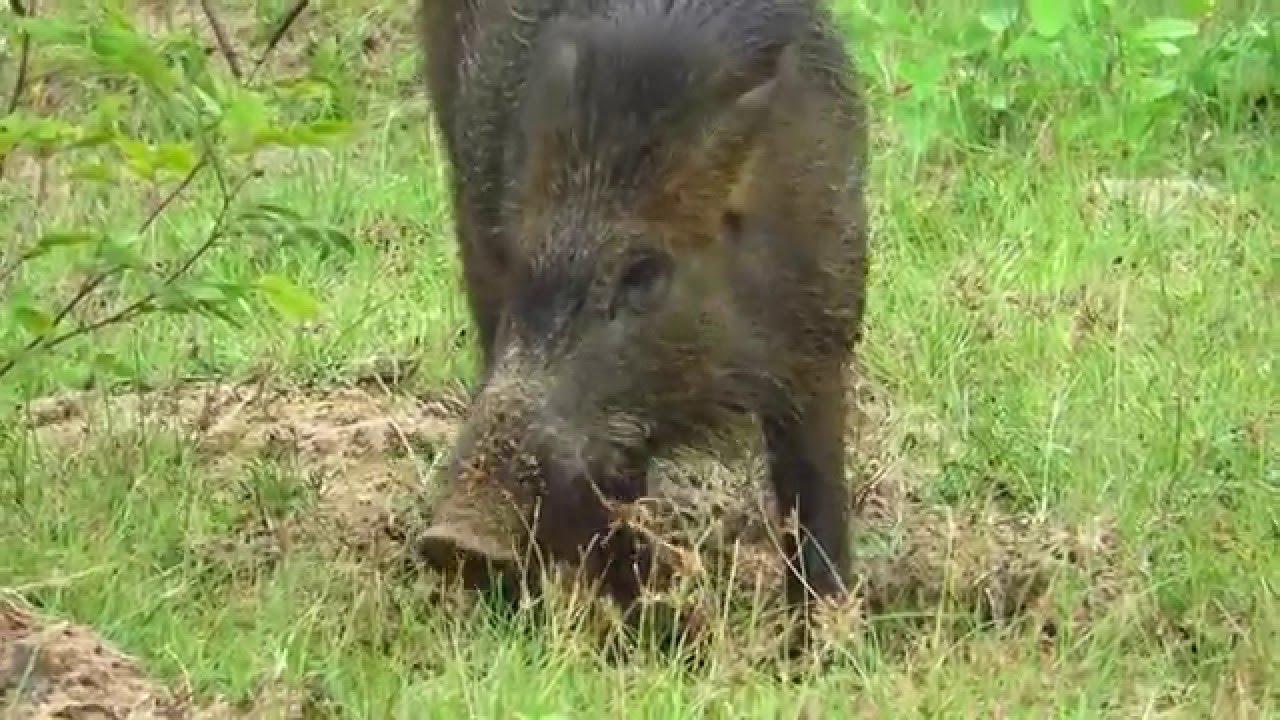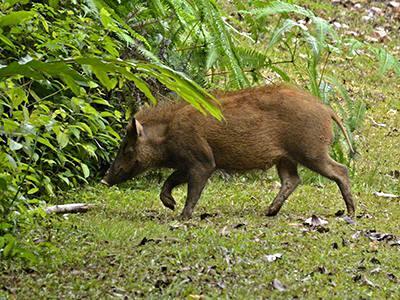The first image is the image on the left, the second image is the image on the right. For the images shown, is this caption "Exactly two living beings are in a forest." true? Answer yes or no. Yes. The first image is the image on the left, the second image is the image on the right. Considering the images on both sides, is "Each image contains exactly one wild pig, which is standing up and lacks distinctive stripes." valid? Answer yes or no. Yes. 